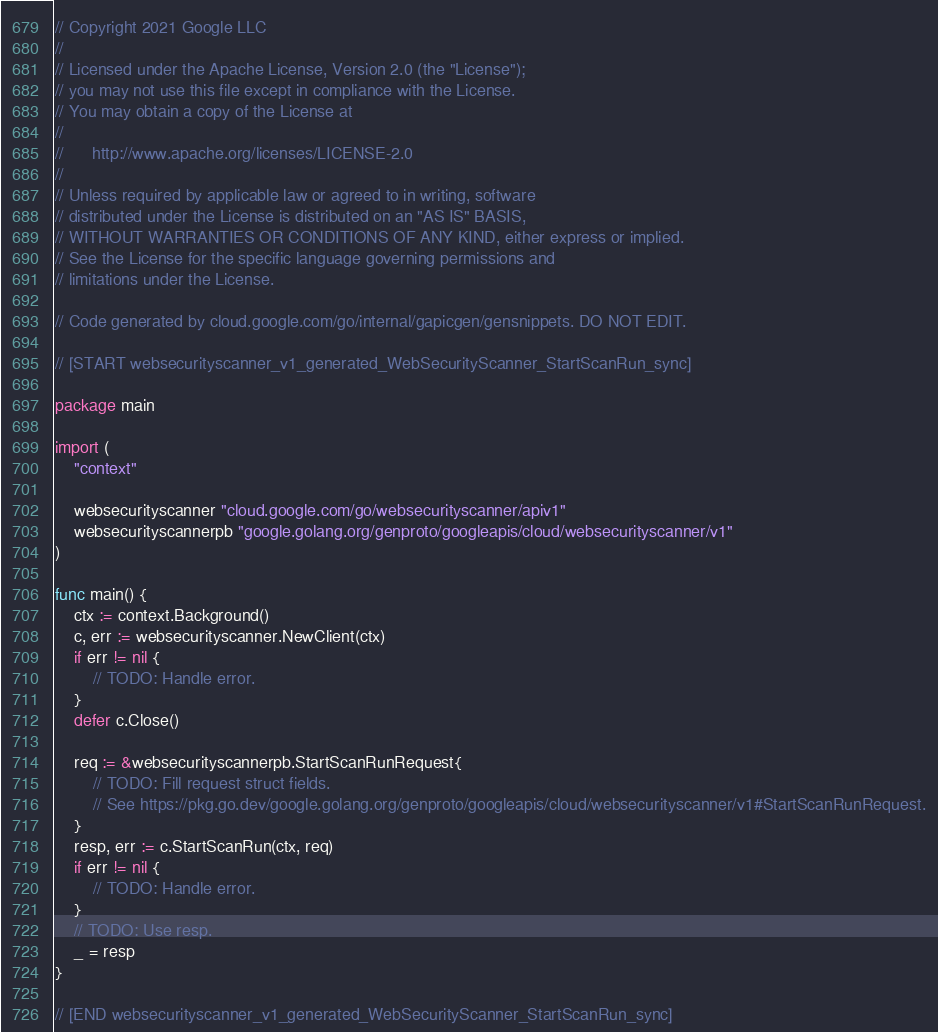<code> <loc_0><loc_0><loc_500><loc_500><_Go_>// Copyright 2021 Google LLC
//
// Licensed under the Apache License, Version 2.0 (the "License");
// you may not use this file except in compliance with the License.
// You may obtain a copy of the License at
//
//      http://www.apache.org/licenses/LICENSE-2.0
//
// Unless required by applicable law or agreed to in writing, software
// distributed under the License is distributed on an "AS IS" BASIS,
// WITHOUT WARRANTIES OR CONDITIONS OF ANY KIND, either express or implied.
// See the License for the specific language governing permissions and
// limitations under the License.

// Code generated by cloud.google.com/go/internal/gapicgen/gensnippets. DO NOT EDIT.

// [START websecurityscanner_v1_generated_WebSecurityScanner_StartScanRun_sync]

package main

import (
	"context"

	websecurityscanner "cloud.google.com/go/websecurityscanner/apiv1"
	websecurityscannerpb "google.golang.org/genproto/googleapis/cloud/websecurityscanner/v1"
)

func main() {
	ctx := context.Background()
	c, err := websecurityscanner.NewClient(ctx)
	if err != nil {
		// TODO: Handle error.
	}
	defer c.Close()

	req := &websecurityscannerpb.StartScanRunRequest{
		// TODO: Fill request struct fields.
		// See https://pkg.go.dev/google.golang.org/genproto/googleapis/cloud/websecurityscanner/v1#StartScanRunRequest.
	}
	resp, err := c.StartScanRun(ctx, req)
	if err != nil {
		// TODO: Handle error.
	}
	// TODO: Use resp.
	_ = resp
}

// [END websecurityscanner_v1_generated_WebSecurityScanner_StartScanRun_sync]
</code> 